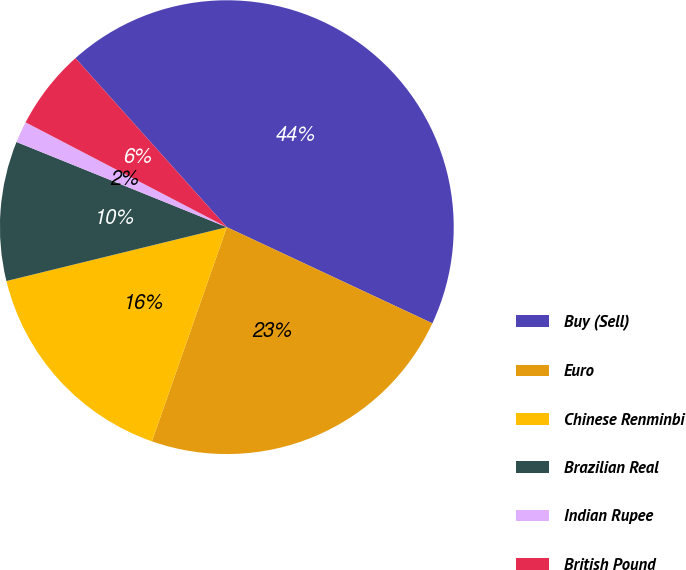Convert chart. <chart><loc_0><loc_0><loc_500><loc_500><pie_chart><fcel>Buy (Sell)<fcel>Euro<fcel>Chinese Renminbi<fcel>Brazilian Real<fcel>Indian Rupee<fcel>British Pound<nl><fcel>43.59%<fcel>23.39%<fcel>15.83%<fcel>9.94%<fcel>1.52%<fcel>5.73%<nl></chart> 